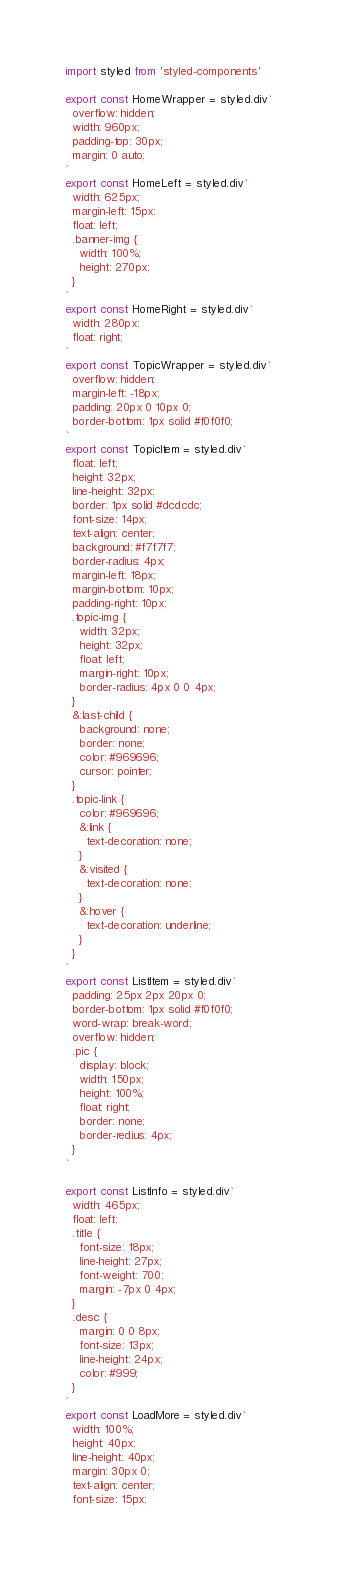Convert code to text. <code><loc_0><loc_0><loc_500><loc_500><_JavaScript_>import styled from 'styled-components'

export const HomeWrapper = styled.div`
  overflow: hidden;
  width: 960px;
  padding-top: 30px;
  margin: 0 auto;
`
export const HomeLeft = styled.div`
  width: 625px;
  margin-left: 15px;
  float: left;
  .banner-img {
    width: 100%;
    height: 270px;
  }
`
export const HomeRight = styled.div`
  width: 280px;
  float: right;
`
export const TopicWrapper = styled.div`
  overflow: hidden;
  margin-left: -18px;
  padding: 20px 0 10px 0;
  border-bottom: 1px solid #f0f0f0;
`
export const TopicItem = styled.div`
  float: left;
  height: 32px;
  line-height: 32px;
  border: 1px solid #dcdcdc;
  font-size: 14px;
  text-align: center;
  background: #f7f7f7;
  border-radius: 4px;
  margin-left: 18px;
  margin-bottom: 10px;
  padding-right: 10px;
  .topic-img {
    width: 32px;
    height: 32px;
    float: left;
    margin-right: 10px;
    border-radius: 4px 0 0 4px;
  }
  &:last-child {
    background: none;
    border: none;
    color: #969696;
    cursor: pointer;
  }
  .topic-link {
    color: #969696; 
    &:link { 
      text-decoration: none; 
    } 
    &:visited { 
      text-decoration: none; 
    } 
    &:hover { 
      text-decoration: underline; 
    }
  }
`
export const ListItem = styled.div`
  padding: 25px 2px 20px 0;
  border-bottom: 1px solid #f0f0f0;
  word-wrap: break-word;
  overflow: hidden;
  .pic {
    display: block;
    width: 150px;
    height: 100%;
    float: right;
    border: none;
    border-redius: 4px;
  }
`

export const ListInfo = styled.div`
  width: 465px;
  float: left;
  .title {
    font-size: 18px;
    line-height: 27px;
    font-weight: 700;
    margin: -7px 0 4px;
  }
  .desc {
    margin: 0 0 8px;
    font-size: 13px;
    line-height: 24px;
    color: #999;
  }
`
export const LoadMore = styled.div`
  width: 100%;
  height: 40px;
  line-height: 40px;
  margin: 30px 0;
  text-align: center;
  font-size: 15px;</code> 